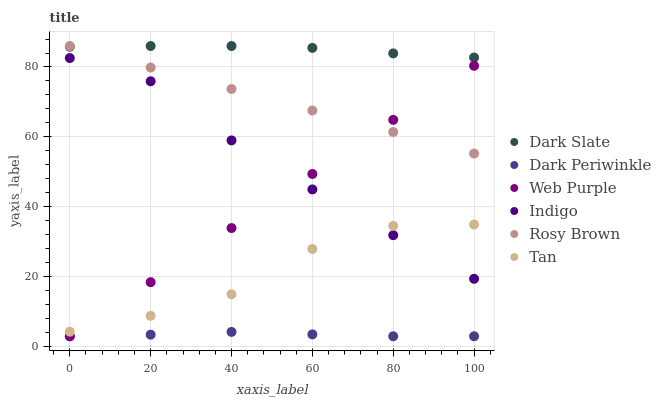Does Dark Periwinkle have the minimum area under the curve?
Answer yes or no. Yes. Does Dark Slate have the maximum area under the curve?
Answer yes or no. Yes. Does Rosy Brown have the minimum area under the curve?
Answer yes or no. No. Does Rosy Brown have the maximum area under the curve?
Answer yes or no. No. Is Rosy Brown the smoothest?
Answer yes or no. Yes. Is Tan the roughest?
Answer yes or no. Yes. Is Dark Slate the smoothest?
Answer yes or no. No. Is Dark Slate the roughest?
Answer yes or no. No. Does Web Purple have the lowest value?
Answer yes or no. Yes. Does Rosy Brown have the lowest value?
Answer yes or no. No. Does Dark Slate have the highest value?
Answer yes or no. Yes. Does Web Purple have the highest value?
Answer yes or no. No. Is Tan less than Dark Slate?
Answer yes or no. Yes. Is Tan greater than Dark Periwinkle?
Answer yes or no. Yes. Does Web Purple intersect Indigo?
Answer yes or no. Yes. Is Web Purple less than Indigo?
Answer yes or no. No. Is Web Purple greater than Indigo?
Answer yes or no. No. Does Tan intersect Dark Slate?
Answer yes or no. No. 